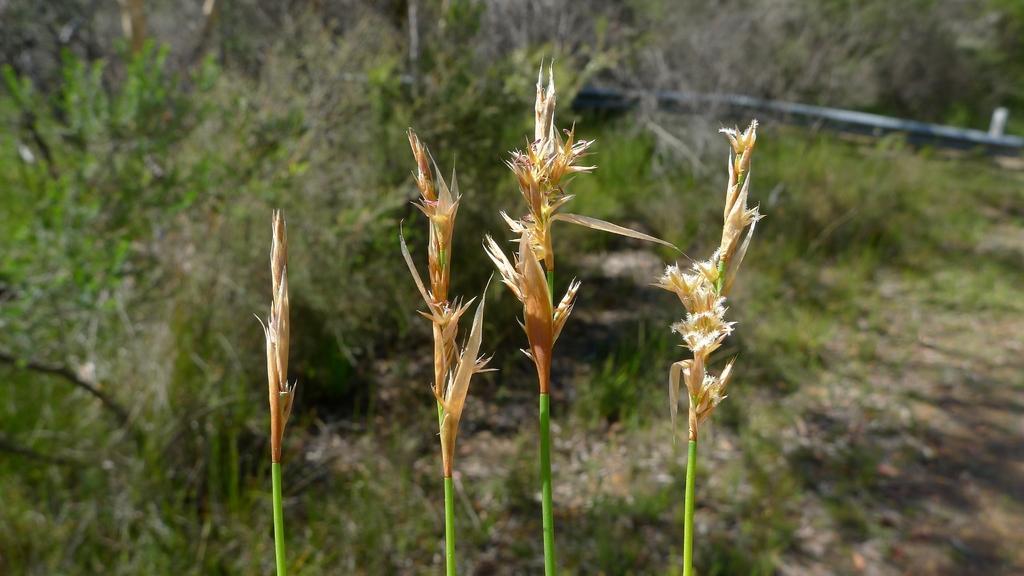Please provide a concise description of this image. Here we can see grass. In the background there are plants and a pipe on the ground. 